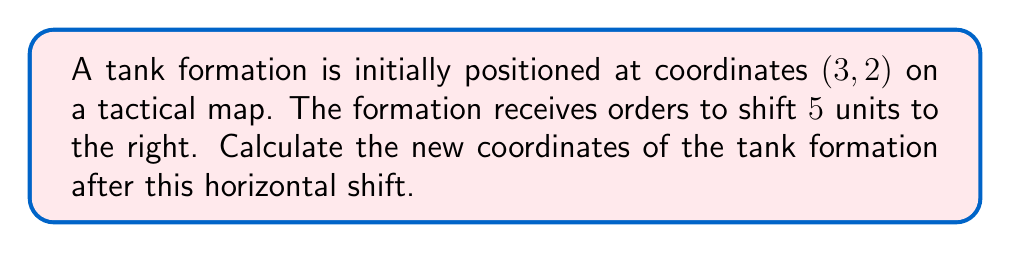Solve this math problem. Let's approach this step-by-step:

1) The initial coordinates of the tank formation are (3, 2).

2) A horizontal shift to the right is represented by adding a positive value to the x-coordinate.

3) The shift is 5 units to the right, so we add 5 to the x-coordinate:
   $x_{new} = x_{old} + 5 = 3 + 5 = 8$

4) The y-coordinate remains unchanged in a horizontal shift:
   $y_{new} = y_{old} = 2$

5) Therefore, the new coordinates after the horizontal shift are (8, 2).

Mathematically, this transformation can be represented as:
$f(x, y) \rightarrow f(x + 5, y)$

where $f(x, y)$ represents the position function of the tank formation.
Answer: (8, 2) 